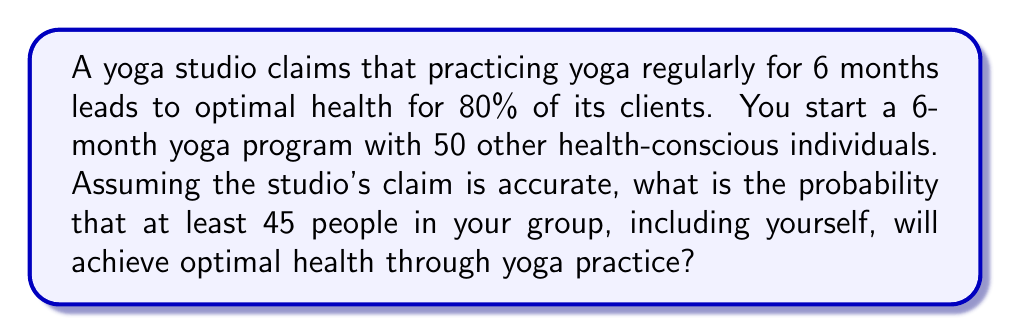Can you answer this question? Let's approach this step-by-step using the binomial distribution:

1) Let X be the number of people achieving optimal health.
2) We have n = 51 (you and 50 others), p = 0.8 (probability of success), and we want P(X ≥ 45).

3) We can calculate this using the complement event: P(X ≥ 45) = 1 - P(X ≤ 44)

4) The probability mass function for the binomial distribution is:

   $$P(X = k) = \binom{n}{k} p^k (1-p)^{n-k}$$

5) We need to sum this for k = 0 to 44:

   $$P(X \leq 44) = \sum_{k=0}^{44} \binom{51}{k} (0.8)^k (0.2)^{51-k}$$

6) This sum is computationally intensive, so we'll use the normal approximation to the binomial distribution.

7) For a binomial distribution, μ = np and σ = √(np(1-p))
   
   $$\mu = 51 * 0.8 = 40.8$$
   $$\sigma = \sqrt{51 * 0.8 * 0.2} = 2.85$$

8) We need to find P(X < 44.5) using the continuity correction:

   $$z = \frac{44.5 - 40.8}{2.85} = 1.30$$

9) Using a standard normal table or calculator, we find:
   
   P(Z < 1.30) ≈ 0.9032

10) Therefore, P(X ≥ 45) = 1 - 0.9032 = 0.0968
Answer: 0.0968 